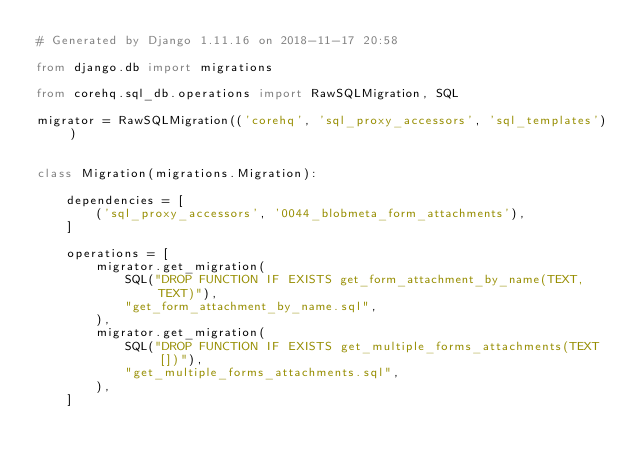Convert code to text. <code><loc_0><loc_0><loc_500><loc_500><_Python_># Generated by Django 1.11.16 on 2018-11-17 20:58

from django.db import migrations

from corehq.sql_db.operations import RawSQLMigration, SQL

migrator = RawSQLMigration(('corehq', 'sql_proxy_accessors', 'sql_templates'))


class Migration(migrations.Migration):

    dependencies = [
        ('sql_proxy_accessors', '0044_blobmeta_form_attachments'),
    ]

    operations = [
        migrator.get_migration(
            SQL("DROP FUNCTION IF EXISTS get_form_attachment_by_name(TEXT, TEXT)"),
            "get_form_attachment_by_name.sql",
        ),
        migrator.get_migration(
            SQL("DROP FUNCTION IF EXISTS get_multiple_forms_attachments(TEXT[])"),
            "get_multiple_forms_attachments.sql",
        ),
    ]
</code> 